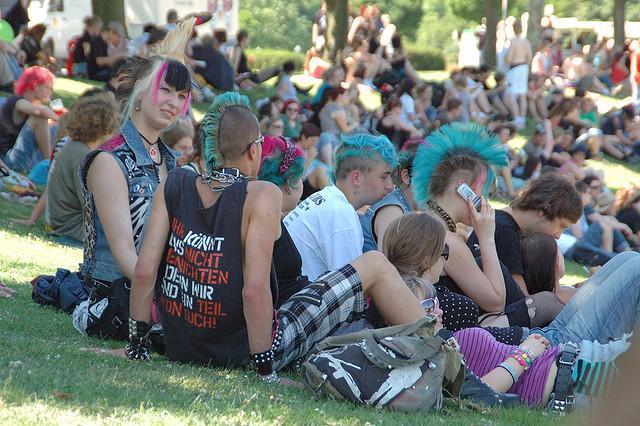How many people are in the picture?
Give a very brief answer. 12. How many handbags are visible?
Give a very brief answer. 2. 